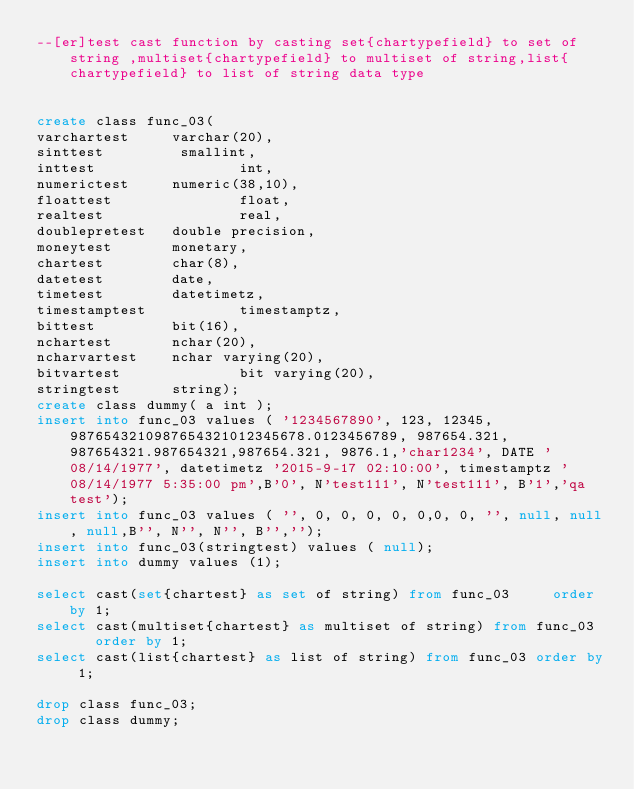Convert code to text. <code><loc_0><loc_0><loc_500><loc_500><_SQL_>--[er]test cast function by casting set{chartypefield} to set of string ,multiset{chartypefield} to multiset of string,list{chartypefield} to list of string data type


create class func_03(
varchartest     varchar(20),
sinttest         smallint,
inttest                 int,
numerictest     numeric(38,10),
floattest               float,
realtest                real,
doublepretest   double precision,
moneytest       monetary,
chartest        char(8),
datetest        date,
timetest        datetimetz,
timestamptest           timestamptz,
bittest         bit(16),
nchartest       nchar(20),
ncharvartest    nchar varying(20),
bitvartest              bit varying(20),
stringtest      string);
create class dummy( a int );
insert into func_03 values ( '1234567890', 123, 12345, 9876543210987654321012345678.0123456789, 987654.321, 987654321.987654321,987654.321, 9876.1,'char1234', DATE '08/14/1977', datetimetz '2015-9-17 02:10:00', timestamptz '08/14/1977 5:35:00 pm',B'0', N'test111', N'test111', B'1','qa test');
insert into func_03 values ( '', 0, 0, 0, 0, 0,0, 0, '', null, null, null,B'', N'', N'', B'','');
insert into func_03(stringtest) values ( null);
insert into dummy values (1);

select cast(set{chartest} as set of string) from func_03	 order by 1;
select cast(multiset{chartest} as multiset of string) from func_03	 order by 1;
select cast(list{chartest} as list of string) from func_03 order by 1;

drop class func_03;
drop class dummy;
</code> 